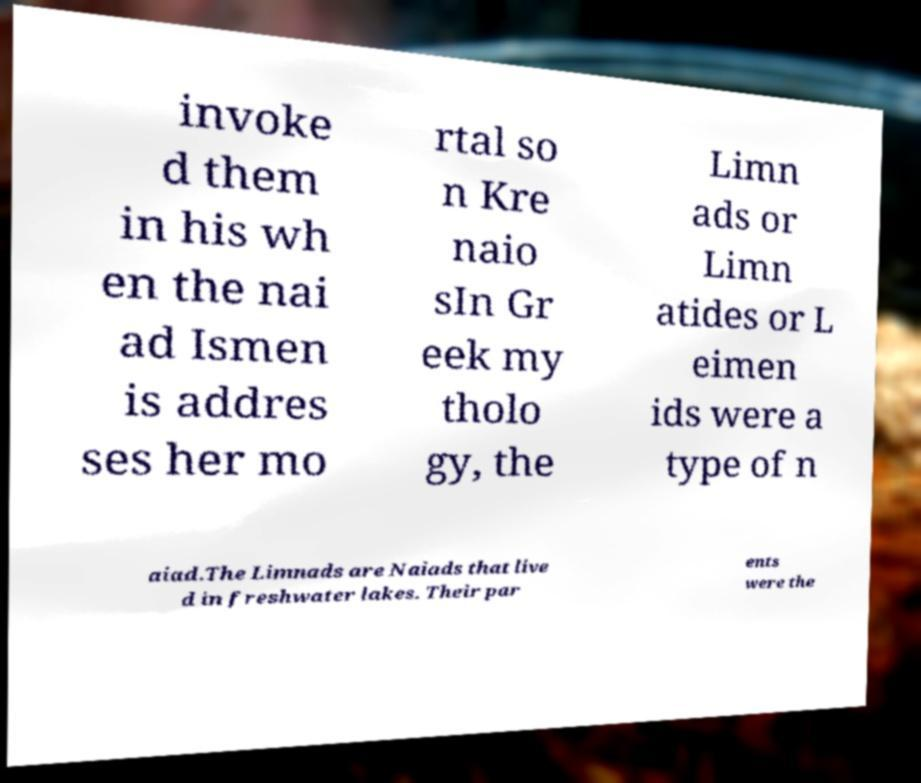There's text embedded in this image that I need extracted. Can you transcribe it verbatim? invoke d them in his wh en the nai ad Ismen is addres ses her mo rtal so n Kre naio sIn Gr eek my tholo gy, the Limn ads or Limn atides or L eimen ids were a type of n aiad.The Limnads are Naiads that live d in freshwater lakes. Their par ents were the 